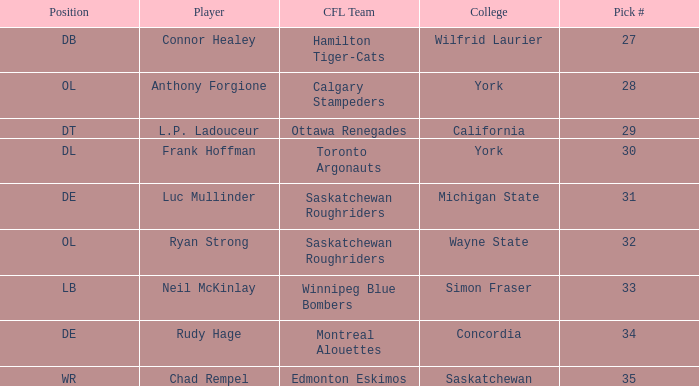Parse the full table. {'header': ['Position', 'Player', 'CFL Team', 'College', 'Pick #'], 'rows': [['DB', 'Connor Healey', 'Hamilton Tiger-Cats', 'Wilfrid Laurier', '27'], ['OL', 'Anthony Forgione', 'Calgary Stampeders', 'York', '28'], ['DT', 'L.P. Ladouceur', 'Ottawa Renegades', 'California', '29'], ['DL', 'Frank Hoffman', 'Toronto Argonauts', 'York', '30'], ['DE', 'Luc Mullinder', 'Saskatchewan Roughriders', 'Michigan State', '31'], ['OL', 'Ryan Strong', 'Saskatchewan Roughriders', 'Wayne State', '32'], ['LB', 'Neil McKinlay', 'Winnipeg Blue Bombers', 'Simon Fraser', '33'], ['DE', 'Rudy Hage', 'Montreal Alouettes', 'Concordia', '34'], ['WR', 'Chad Rempel', 'Edmonton Eskimos', 'Saskatchewan', '35']]} What was the highest Pick # for the College of Simon Fraser? 33.0. 